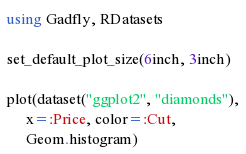Convert code to text. <code><loc_0><loc_0><loc_500><loc_500><_Julia_>using Gadfly, RDatasets

set_default_plot_size(6inch, 3inch)

plot(dataset("ggplot2", "diamonds"),
     x=:Price, color=:Cut,
     Geom.histogram)
</code> 